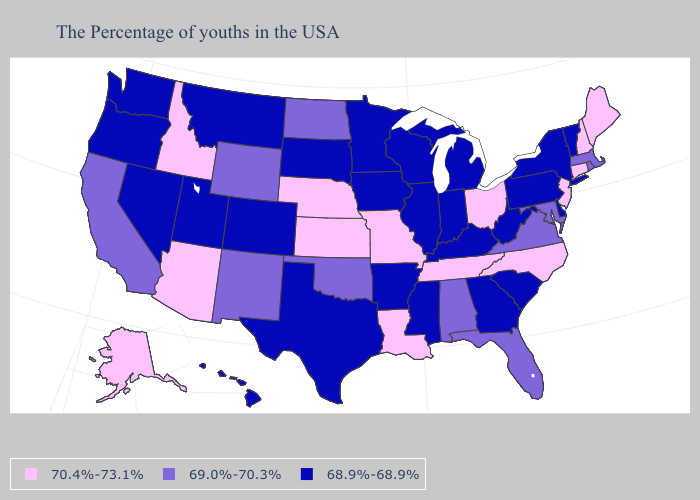Among the states that border Texas , which have the highest value?
Be succinct. Louisiana. What is the value of Iowa?
Give a very brief answer. 68.9%-68.9%. Does Virginia have the lowest value in the USA?
Concise answer only. No. What is the value of Delaware?
Keep it brief. 68.9%-68.9%. What is the value of Montana?
Give a very brief answer. 68.9%-68.9%. Does Colorado have the highest value in the West?
Concise answer only. No. Name the states that have a value in the range 69.0%-70.3%?
Concise answer only. Massachusetts, Rhode Island, Maryland, Virginia, Florida, Alabama, Oklahoma, North Dakota, Wyoming, New Mexico, California. Which states hav the highest value in the Northeast?
Short answer required. Maine, New Hampshire, Connecticut, New Jersey. Among the states that border Maryland , which have the highest value?
Answer briefly. Virginia. Which states have the lowest value in the Northeast?
Give a very brief answer. Vermont, New York, Pennsylvania. Does the map have missing data?
Give a very brief answer. No. What is the lowest value in the Northeast?
Short answer required. 68.9%-68.9%. Does Georgia have the lowest value in the USA?
Concise answer only. Yes. Name the states that have a value in the range 68.9%-68.9%?
Write a very short answer. Vermont, New York, Delaware, Pennsylvania, South Carolina, West Virginia, Georgia, Michigan, Kentucky, Indiana, Wisconsin, Illinois, Mississippi, Arkansas, Minnesota, Iowa, Texas, South Dakota, Colorado, Utah, Montana, Nevada, Washington, Oregon, Hawaii. Among the states that border Michigan , which have the lowest value?
Concise answer only. Indiana, Wisconsin. 